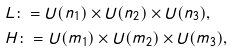<formula> <loc_0><loc_0><loc_500><loc_500>& L \colon = U ( n _ { 1 } ) \times U ( n _ { 2 } ) \times U ( n _ { 3 } ) , \\ & H \colon = U ( m _ { 1 } ) \times U ( m _ { 2 } ) \times U ( m _ { 3 } ) ,</formula> 